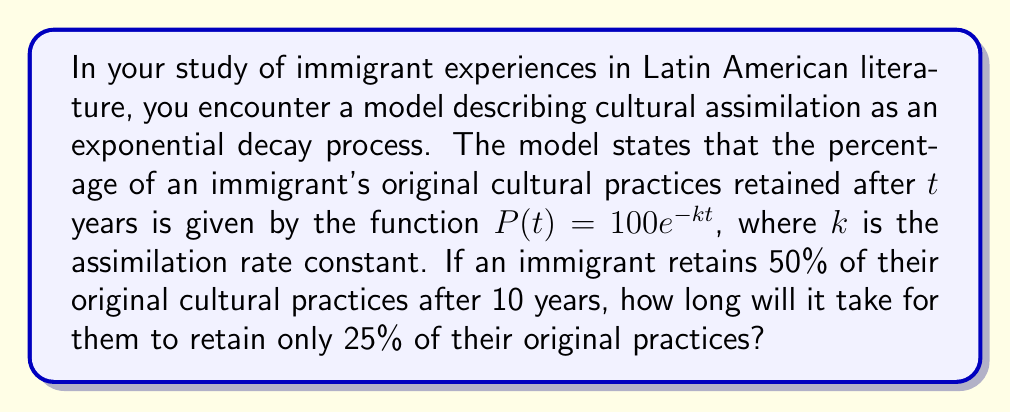What is the answer to this math problem? Let's approach this step-by-step:

1) We're given that $P(t) = 100e^{-kt}$

2) We know that after 10 years, 50% of practices are retained. Let's use this to find k:
   
   $50 = 100e^{-k(10)}$
   
   $0.5 = e^{-10k}$

3) Taking the natural log of both sides:
   
   $\ln(0.5) = -10k$

4) Solving for k:
   
   $k = -\frac{\ln(0.5)}{10} \approx 0.0693$

5) Now, we want to find t when P(t) = 25:
   
   $25 = 100e^{-0.0693t}$
   
   $0.25 = e^{-0.0693t}$

6) Taking the natural log of both sides:
   
   $\ln(0.25) = -0.0693t$

7) Solving for t:
   
   $t = -\frac{\ln(0.25)}{0.0693} \approx 20$

Therefore, it will take approximately 20 years for the immigrant to retain only 25% of their original cultural practices.
Answer: 20 years 